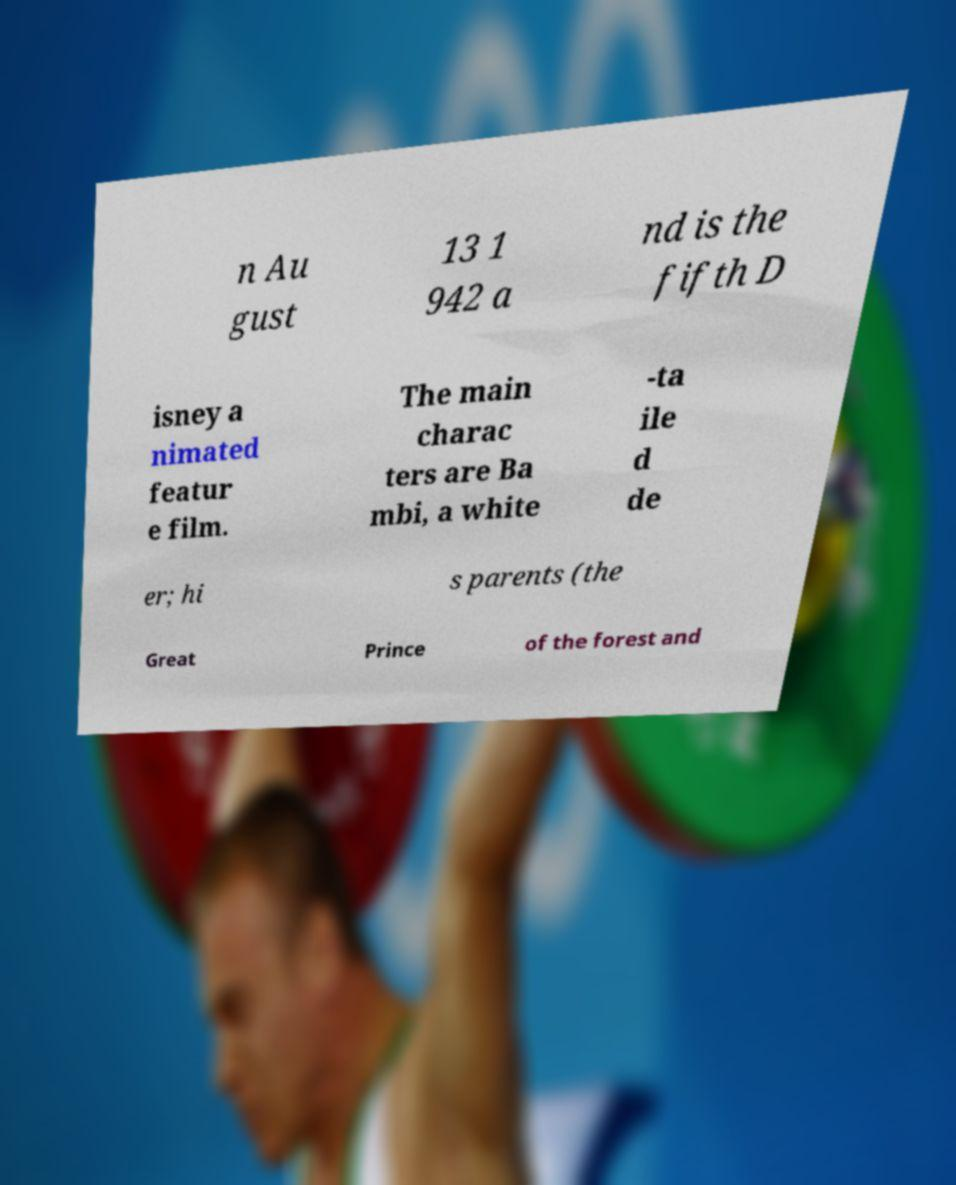Please read and relay the text visible in this image. What does it say? n Au gust 13 1 942 a nd is the fifth D isney a nimated featur e film. The main charac ters are Ba mbi, a white -ta ile d de er; hi s parents (the Great Prince of the forest and 